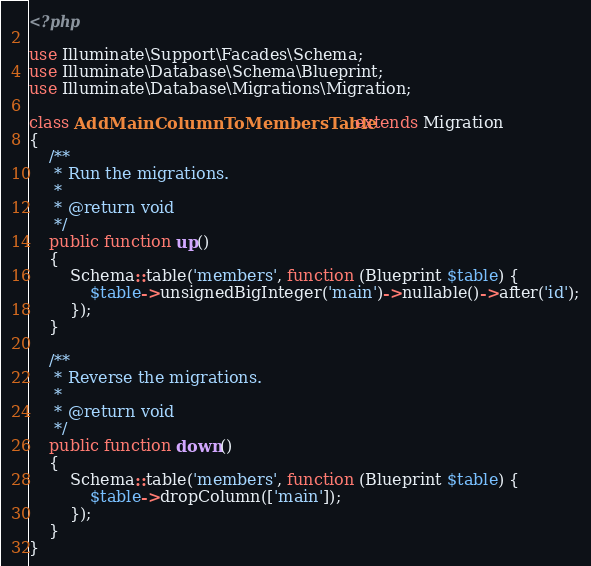Convert code to text. <code><loc_0><loc_0><loc_500><loc_500><_PHP_><?php

use Illuminate\Support\Facades\Schema;
use Illuminate\Database\Schema\Blueprint;
use Illuminate\Database\Migrations\Migration;

class AddMainColumnToMembersTable extends Migration
{
    /**
     * Run the migrations.
     *
     * @return void
     */
    public function up()
    {
        Schema::table('members', function (Blueprint $table) {
            $table->unsignedBigInteger('main')->nullable()->after('id');
        });
    }

    /**
     * Reverse the migrations.
     *
     * @return void
     */
    public function down()
    {
        Schema::table('members', function (Blueprint $table) {
            $table->dropColumn(['main']);
        });
    }
}
</code> 